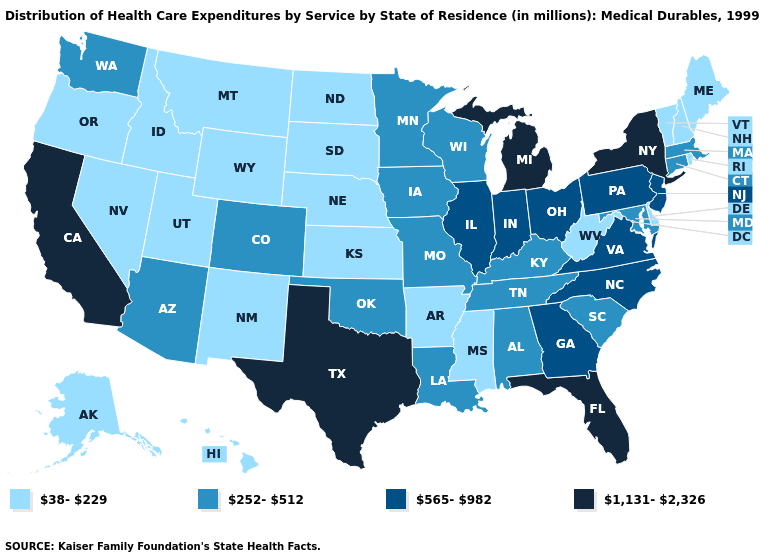What is the highest value in the MidWest ?
Quick response, please. 1,131-2,326. Which states have the highest value in the USA?
Short answer required. California, Florida, Michigan, New York, Texas. Name the states that have a value in the range 252-512?
Be succinct. Alabama, Arizona, Colorado, Connecticut, Iowa, Kentucky, Louisiana, Maryland, Massachusetts, Minnesota, Missouri, Oklahoma, South Carolina, Tennessee, Washington, Wisconsin. What is the lowest value in the USA?
Give a very brief answer. 38-229. Does Utah have the same value as Idaho?
Concise answer only. Yes. Name the states that have a value in the range 252-512?
Answer briefly. Alabama, Arizona, Colorado, Connecticut, Iowa, Kentucky, Louisiana, Maryland, Massachusetts, Minnesota, Missouri, Oklahoma, South Carolina, Tennessee, Washington, Wisconsin. Name the states that have a value in the range 38-229?
Keep it brief. Alaska, Arkansas, Delaware, Hawaii, Idaho, Kansas, Maine, Mississippi, Montana, Nebraska, Nevada, New Hampshire, New Mexico, North Dakota, Oregon, Rhode Island, South Dakota, Utah, Vermont, West Virginia, Wyoming. Does Texas have the highest value in the USA?
Give a very brief answer. Yes. What is the value of New Mexico?
Keep it brief. 38-229. Does the first symbol in the legend represent the smallest category?
Concise answer only. Yes. Among the states that border Maryland , which have the highest value?
Give a very brief answer. Pennsylvania, Virginia. Name the states that have a value in the range 252-512?
Be succinct. Alabama, Arizona, Colorado, Connecticut, Iowa, Kentucky, Louisiana, Maryland, Massachusetts, Minnesota, Missouri, Oklahoma, South Carolina, Tennessee, Washington, Wisconsin. How many symbols are there in the legend?
Answer briefly. 4. What is the value of New Hampshire?
Quick response, please. 38-229. Does Utah have the highest value in the West?
Give a very brief answer. No. 